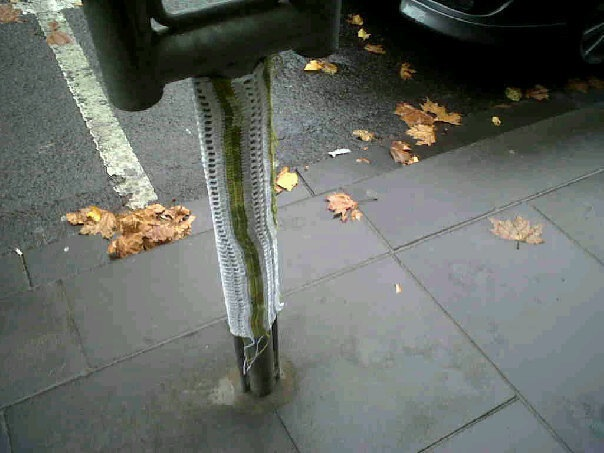Describe the objects in this image and their specific colors. I can see parking meter in gray, black, darkgreen, and darkgray tones and car in gray, black, darkgray, and purple tones in this image. 